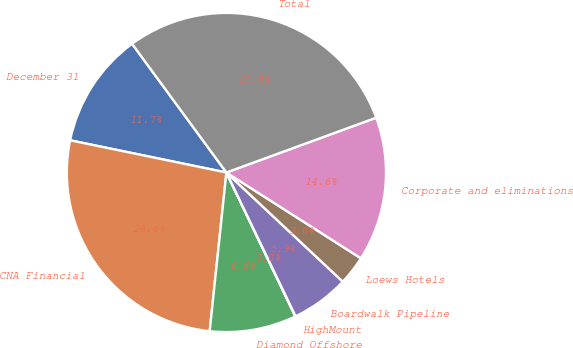Convert chart. <chart><loc_0><loc_0><loc_500><loc_500><pie_chart><fcel>December 31<fcel>CNA Financial<fcel>Diamond Offshore<fcel>HighMount<fcel>Boardwalk Pipeline<fcel>Loews Hotels<fcel>Corporate and eliminations<fcel>Total<nl><fcel>11.7%<fcel>26.56%<fcel>8.78%<fcel>0.03%<fcel>5.87%<fcel>2.95%<fcel>14.62%<fcel>29.48%<nl></chart> 